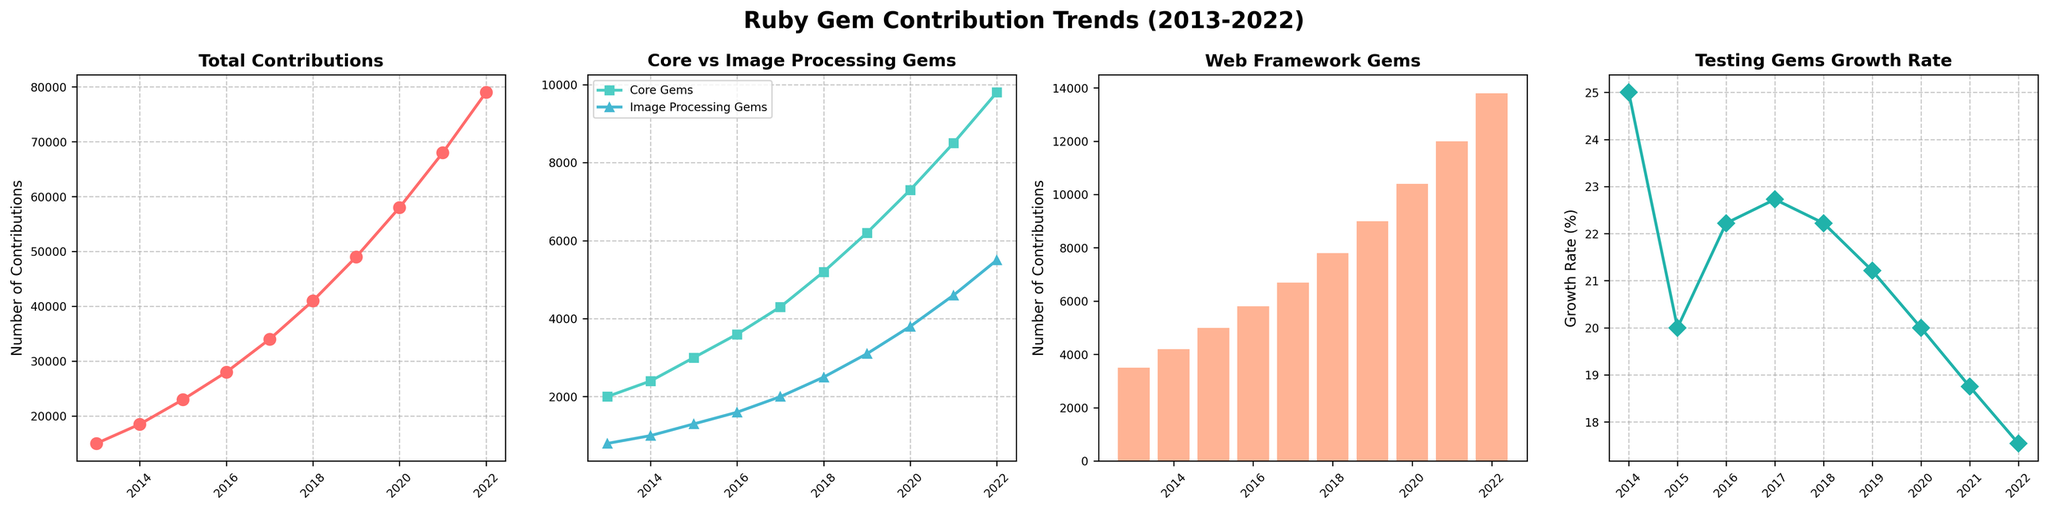Which year had the highest total contributions? The first subplot shows the total contributions trend. We can easily see the peak value occurs in the year 2022, where it reaches 79,000 contributions.
Answer: 2022 How many more contributions were made to web framework gems in 2022 compared to 2013? The bar chart in the third subplot shows the number of web framework gem contributions each year. In 2022, there were 13,800 contributions, whereas in 2013, there were 3,500 contributions. The difference is 13,800 - 3,500.
Answer: 10,300 Which year experienced the highest growth rate in testing gem contributions? The fourth subplot shows the testing gem growth rate year by year. By observing the slope of the plotted line, 2018 shows the highest growth rate visually.
Answer: 2018 What's the sum of contributions to core gems and image processing gems in 2020? The second subplot shows the contributions to core gems and image processing gems. For 2020, core gems have 7,300 contributions and image processing gems have 3,800 contributions. The sum is 7,300 + 3,800.
Answer: 11,100 Was the number of contributions to image processing gems in 2019 higher than in 2017? In the second subplot, image processing gems contributions are higher in 2019 (3,100) than in 2017 (2,000).
Answer: Yes Compare the contributions to web framework gems and core gems in the year 2021. Which had more contributions? From the bar chart and the line plot in the third and second subplots respectively for 2021, web framework gems had 12,000 contributions and core gems had 8,500 contributions. Therefore, web framework gems had more contributions.
Answer: Web framework gems What was the approximate average yearly growth rate of testing gems from 2013 to 2022? To find the average yearly growth rate, we sum the yearly growth rates given in the fourth subplot and then divide by the number of years which is 9 (from 2014 to 2022). Growth Rates: [(20%, 25%, 22%, 23%, 23%, 21%, 20%, 19%, 18%), summing them 190% / 9 years]
Answer: Approx. 21% From 2014 to 2022 which type of gem had the most consistent year-on-year increase? By observing all four subplots, especially the first and second ones, web framework gems show a consistent and steep increase in contributions every year compared to the other gem types.
Answer: Web framework gems Compare the trends for core gems and image processing gems. Did they both grow at the same rate? As shown in the second subplot, both core and image processing gems have rising trends, but core gems grew at a faster rate since the gap between them increases over the years.
Answer: No Which color represents the testing gems growth rate in the plots? In the fourth subplot, the testing gems growth rate is plotted using a line with diamond markers and the line is colored in greenish-blue.
Answer: Greenish-blue 